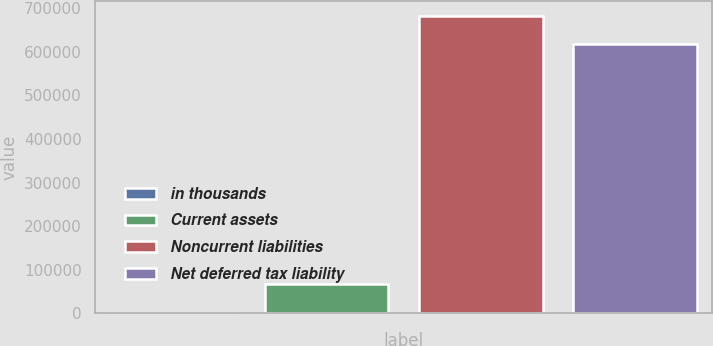Convert chart to OTSL. <chart><loc_0><loc_0><loc_500><loc_500><bar_chart><fcel>in thousands<fcel>Current assets<fcel>Noncurrent liabilities<fcel>Net deferred tax liability<nl><fcel>2012<fcel>67547.5<fcel>682206<fcel>616671<nl></chart> 